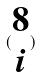Convert formula to latex. <formula><loc_0><loc_0><loc_500><loc_500>( \begin{matrix} 8 \\ i \end{matrix} )</formula> 